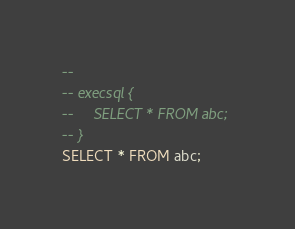<code> <loc_0><loc_0><loc_500><loc_500><_SQL_>-- 
-- execsql {
--     SELECT * FROM abc;
-- }
SELECT * FROM abc;</code> 